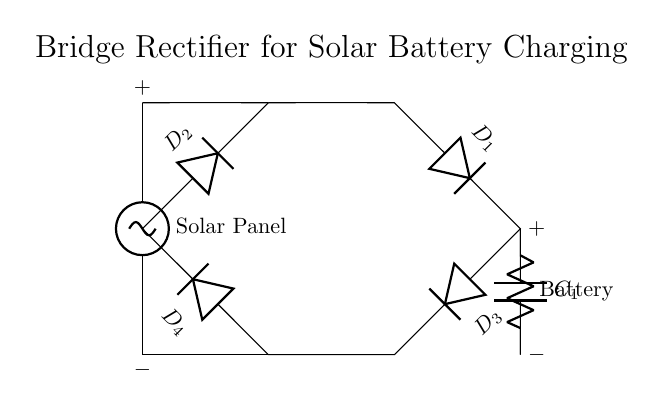What is the type of circuit represented? The circuit is a bridge rectifier, which is identified by the arrangement of four diodes in a bridge configuration that converts AC to DC.
Answer: bridge rectifier How many diodes are used in this circuit? There are four diodes in the bridge rectifier, labeled as D1, D2, D3, and D4, which can be counted in the diagram.
Answer: four What is the primary purpose of this circuit? The primary purpose is to charge a battery from a solar panel by converting the AC output of the solar panel into usable DC for the battery.
Answer: charge battery What component is connected to the output of the rectifier? A capacitor labeled C1 and a load labeled "Battery" are both connected at the output of the rectifier to store energy and supply power.
Answer: Battery What does the symbol next to the solar panel represent? The symbol of the solar panel represents a voltage source which indicates that it generates electrical energy from sunlight.
Answer: voltage source Why is a capacitor used in this circuit? A capacitor is used to smooth the output voltage from the rectifier, reducing ripple and providing a more stable DC voltage for the battery charging process.
Answer: smooth voltage How do the diodes function in this configuration? The diodes conduct current in one direction only, allowing the rectifier to convert both halves of the AC waveform into DC by alternately conducting, ensuring that the current flows in a single direction towards the battery.
Answer: convert AC to DC 